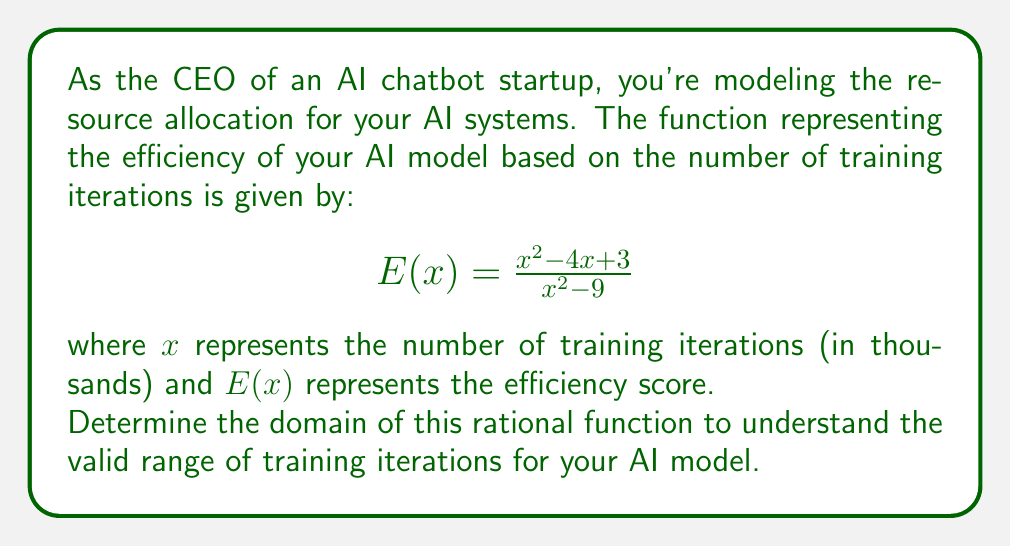Solve this math problem. To determine the domain of the rational function, we need to find the values of $x$ for which the function is defined. The function will be undefined when its denominator equals zero.

Step 1: Set the denominator equal to zero and solve for $x$.
$$x^2 - 9 = 0$$
$$(x+3)(x-3) = 0$$
$$x = -3 \text{ or } x = 3$$

Step 2: Analyze the numerator for potential simplification.
The numerator $x^2 - 4x + 3$ can be factored as $(x-1)(x-3)$.

Step 3: Rewrite the function in factored form.
$$E(x) = \frac{(x-1)(x-3)}{(x+3)(x-3)}$$

Step 4: Observe that $(x-3)$ appears in both numerator and denominator, allowing for cancellation.
$$E(x) = \frac{x-1}{x+3}, \text{ where } x \neq 3$$

Step 5: Determine the domain.
The function is defined for all real numbers except when $x = -3$ (from the new denominator) and $x = 3$ (from the cancellation step).

Therefore, the domain is all real numbers except -3 and 3, which in interval notation is:
$$(-\infty, -3) \cup (-3, 3) \cup (3, \infty)$$

This means your AI model's efficiency function is valid for any number of training iterations except exactly 3,000 or -3,000 (remembering that $x$ represents thousands of iterations).
Answer: $(-\infty, -3) \cup (-3, 3) \cup (3, \infty)$ 